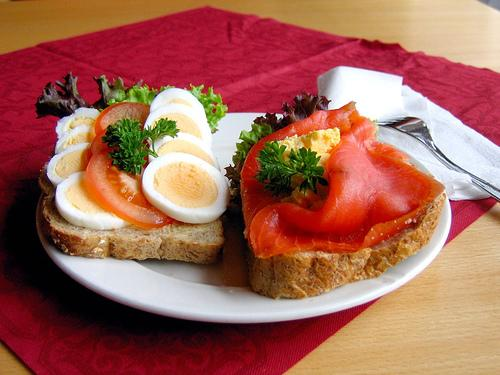Which food came from an unborn animal? Please explain your reasoning. eggs. Vegetables and bread do not come from animals. the meat came from a born animal. 